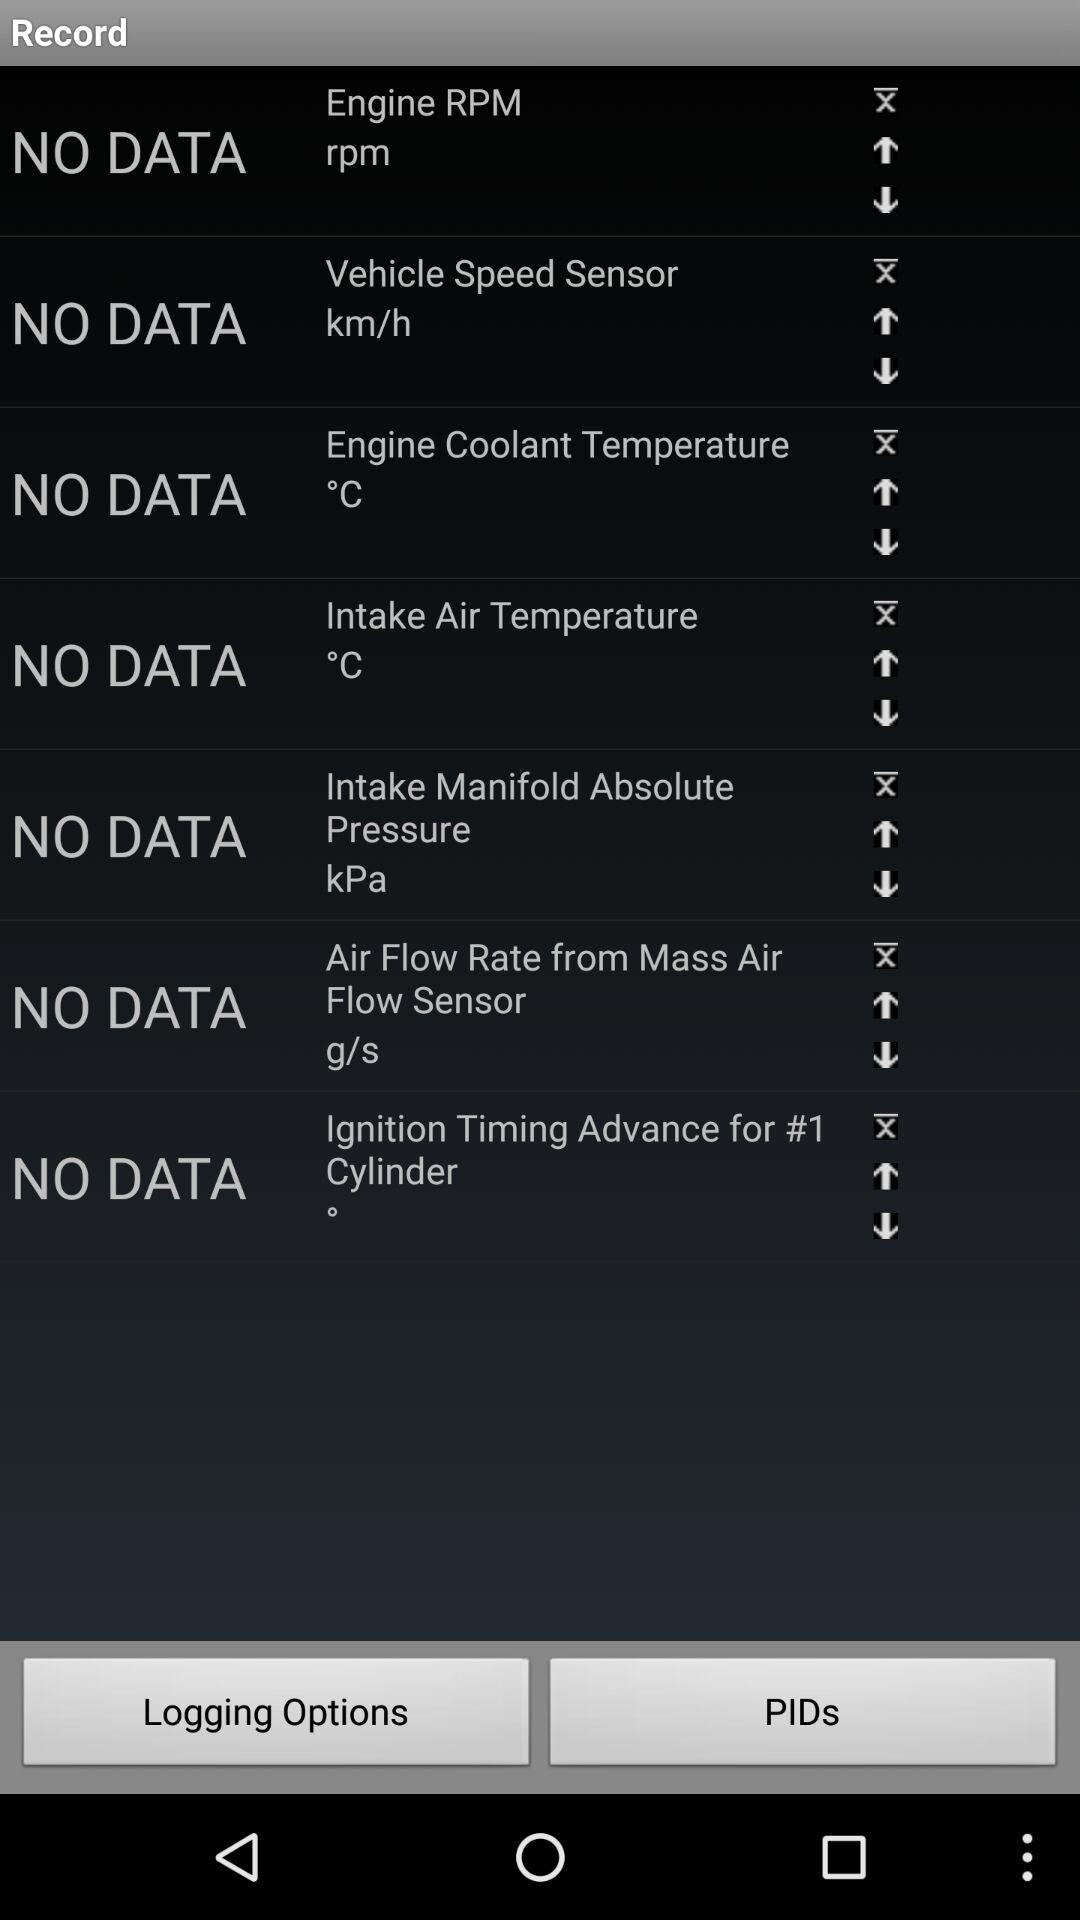In which unit can we measure engine speed? You can measure engine speed in rpm. 